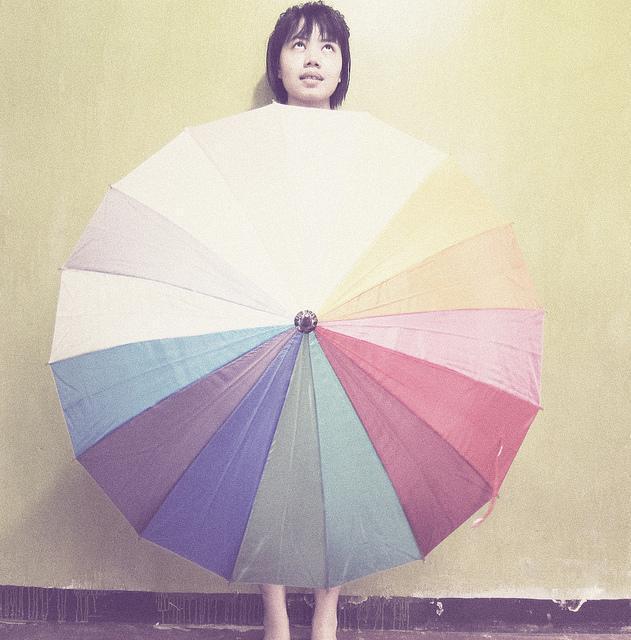How many objects is this person holding?
Give a very brief answer. 1. How many umbrellas?
Give a very brief answer. 1. How many umbrellas are there?
Give a very brief answer. 1. How many tracks have a train on them?
Give a very brief answer. 0. 